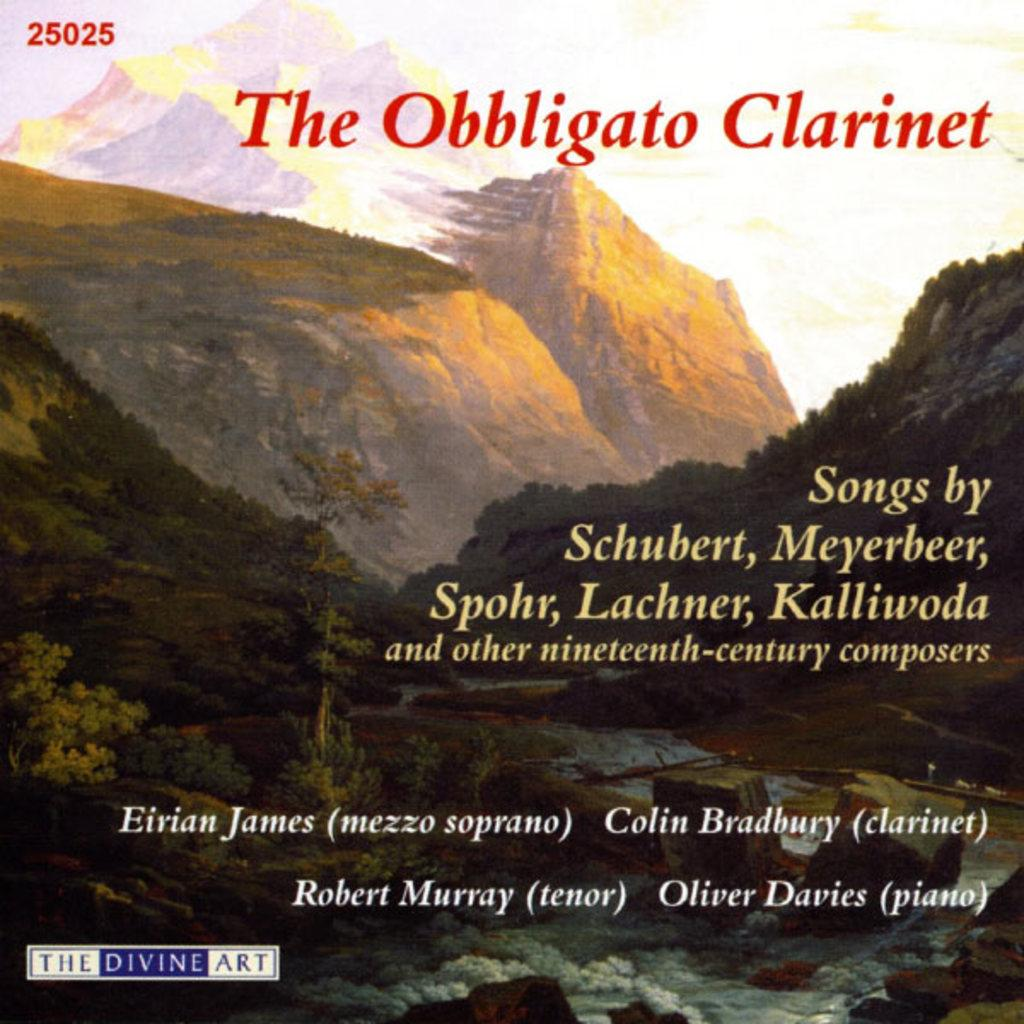<image>
Describe the image concisely. The cover art for The obbligato Clarinet, a collection of 19th century composers. 